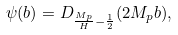Convert formula to latex. <formula><loc_0><loc_0><loc_500><loc_500>\psi ( b ) = D _ { \frac { M _ { p } } { H } - \frac { 1 } { 2 } } ( 2 M _ { p } b ) ,</formula> 